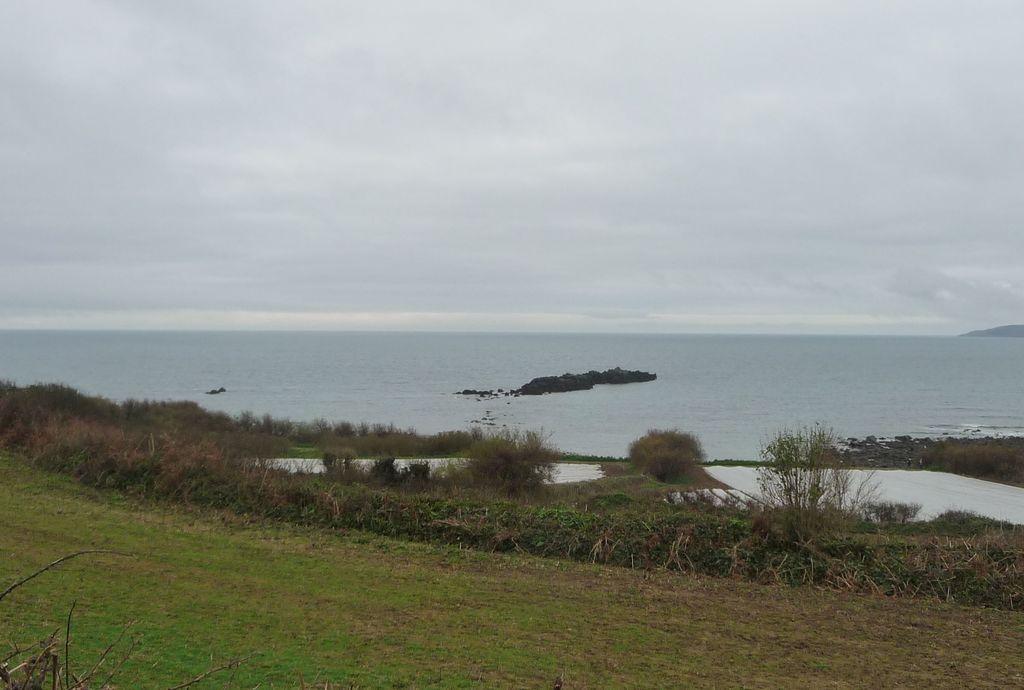Can you describe this image briefly? In this image I can see the grass in green color, background I can see water and sky in white color. 